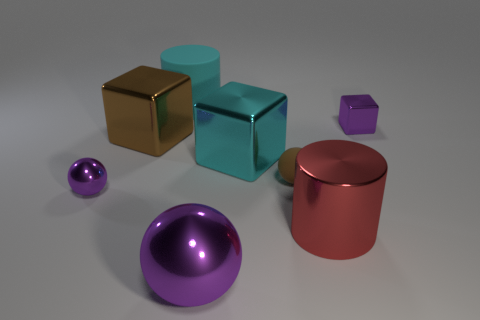There is a small metal thing to the left of the red shiny cylinder; does it have the same color as the metallic cylinder?
Give a very brief answer. No. What number of tiny shiny things are there?
Give a very brief answer. 2. Is the material of the tiny ball left of the small brown matte object the same as the big red thing?
Ensure brevity in your answer.  Yes. Are there any other things that are the same material as the large purple object?
Make the answer very short. Yes. There is a purple thing behind the purple metallic thing on the left side of the rubber cylinder; what number of shiny cubes are in front of it?
Your response must be concise. 2. What size is the shiny cylinder?
Ensure brevity in your answer.  Large. Is the large sphere the same color as the large shiny cylinder?
Your answer should be compact. No. There is a cylinder in front of the large brown metallic thing; what size is it?
Provide a succinct answer. Large. There is a small metallic object to the left of the big cyan matte cylinder; is it the same color as the big metallic cube that is right of the big rubber thing?
Keep it short and to the point. No. What number of other objects are there of the same shape as the cyan metal thing?
Offer a very short reply. 2. 